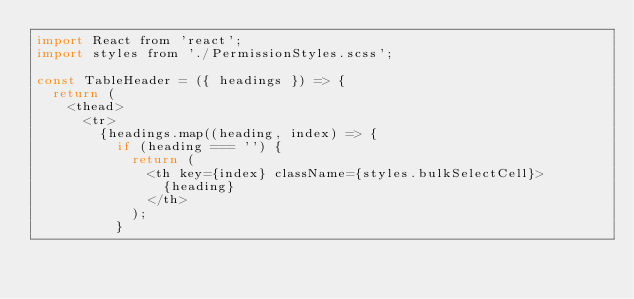Convert code to text. <code><loc_0><loc_0><loc_500><loc_500><_JavaScript_>import React from 'react';
import styles from './PermissionStyles.scss';

const TableHeader = ({ headings }) => {
  return (
    <thead>
      <tr>
        {headings.map((heading, index) => {
          if (heading === '') {
            return (
              <th key={index} className={styles.bulkSelectCell}>
                {heading}
              </th>
            );
          }</code> 